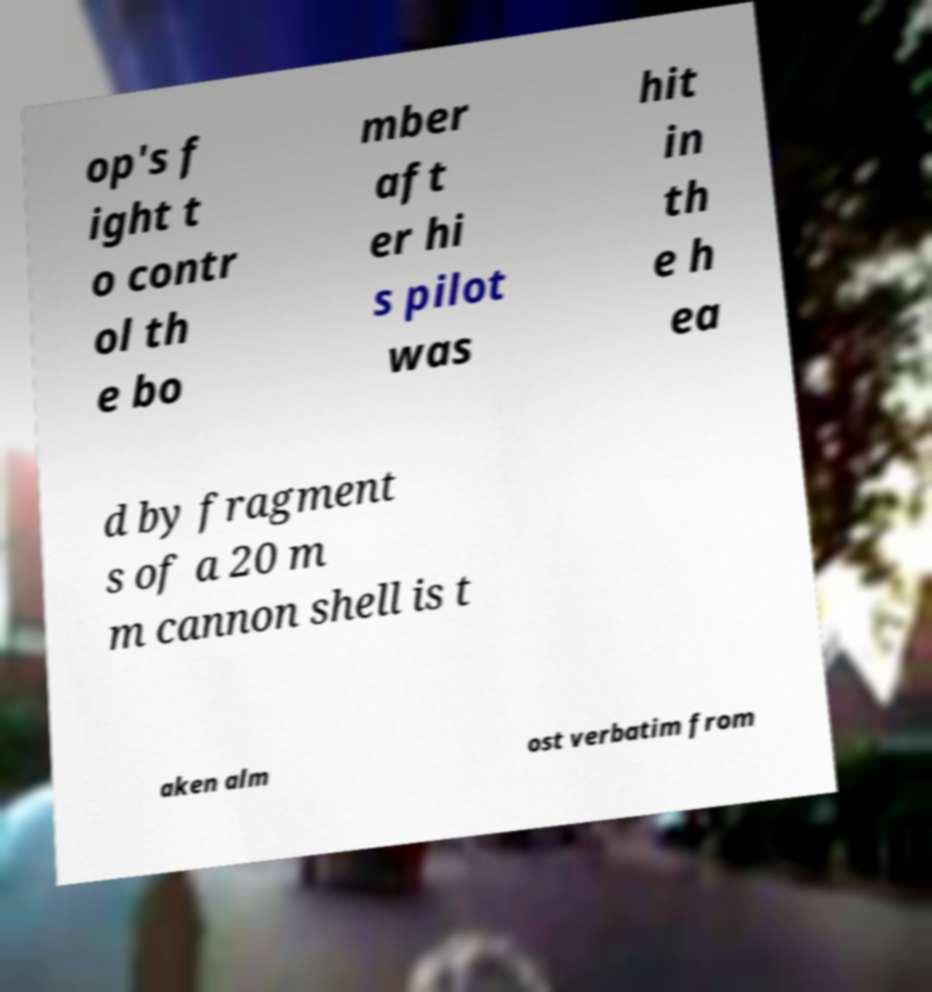Can you read and provide the text displayed in the image?This photo seems to have some interesting text. Can you extract and type it out for me? op's f ight t o contr ol th e bo mber aft er hi s pilot was hit in th e h ea d by fragment s of a 20 m m cannon shell is t aken alm ost verbatim from 